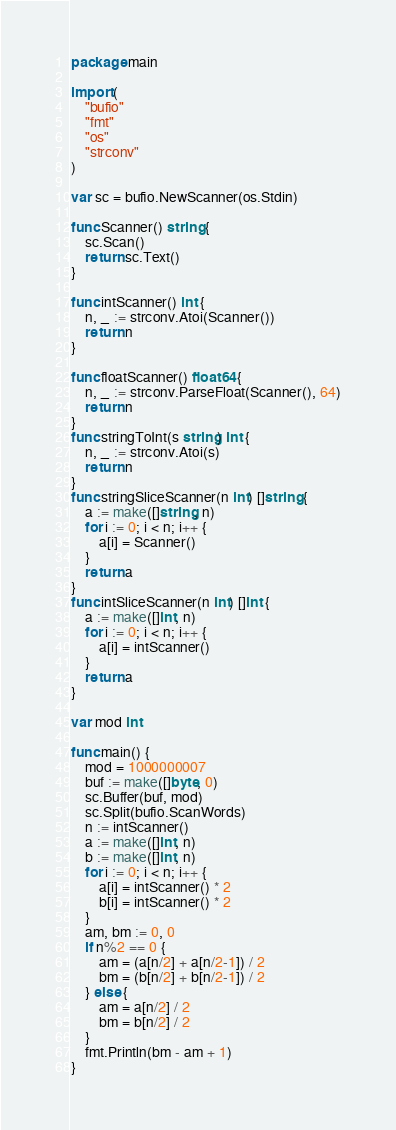Convert code to text. <code><loc_0><loc_0><loc_500><loc_500><_Go_>package main

import (
	"bufio"
	"fmt"
	"os"
	"strconv"
)

var sc = bufio.NewScanner(os.Stdin)

func Scanner() string {
	sc.Scan()
	return sc.Text()
}

func intScanner() int {
	n, _ := strconv.Atoi(Scanner())
	return n
}

func floatScanner() float64 {
	n, _ := strconv.ParseFloat(Scanner(), 64)
	return n
}
func stringToInt(s string) int {
	n, _ := strconv.Atoi(s)
	return n
}
func stringSliceScanner(n int) []string {
	a := make([]string, n)
	for i := 0; i < n; i++ {
		a[i] = Scanner()
	}
	return a
}
func intSliceScanner(n int) []int {
	a := make([]int, n)
	for i := 0; i < n; i++ {
		a[i] = intScanner()
	}
	return a
}

var mod int

func main() {
	mod = 1000000007
	buf := make([]byte, 0)
	sc.Buffer(buf, mod)
	sc.Split(bufio.ScanWords)
	n := intScanner()
	a := make([]int, n)
	b := make([]int, n)
	for i := 0; i < n; i++ {
		a[i] = intScanner() * 2
		b[i] = intScanner() * 2
	}
	am, bm := 0, 0
	if n%2 == 0 {
		am = (a[n/2] + a[n/2-1]) / 2
		bm = (b[n/2] + b[n/2-1]) / 2
	} else {
		am = a[n/2] / 2
		bm = b[n/2] / 2
	}
	fmt.Println(bm - am + 1)
}
</code> 